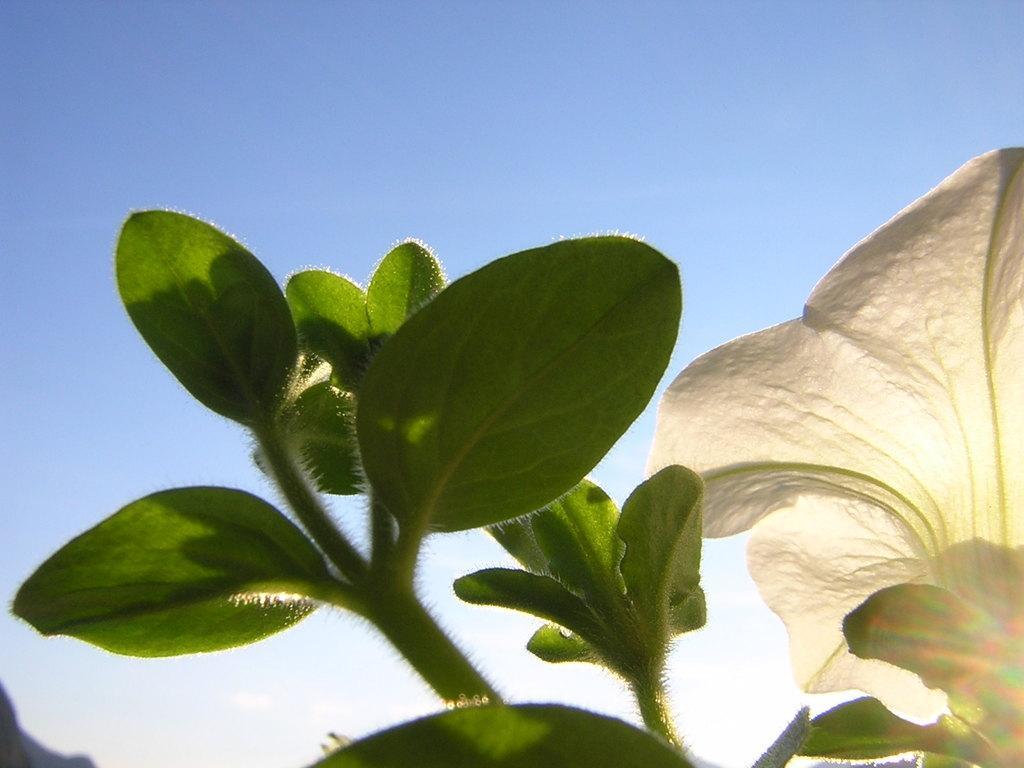Could you give a brief overview of what you see in this image? In this picture I can see there is a flower, it is in white color and is attached to the plant and it has leaves and the sky is clear. 